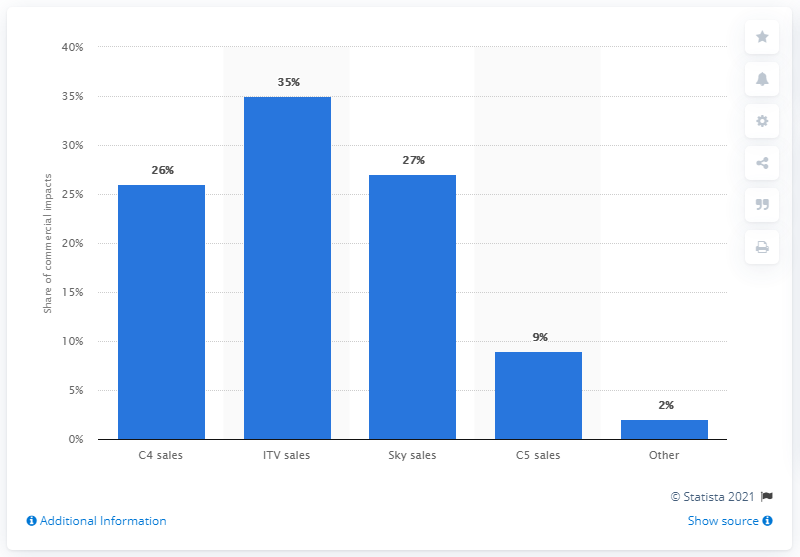Specify some key components in this picture. What is the least value that can be represented by a number between 2 and 4, inclusive? The C4 sales and Sky sales houses have a difference of 1% between them. 